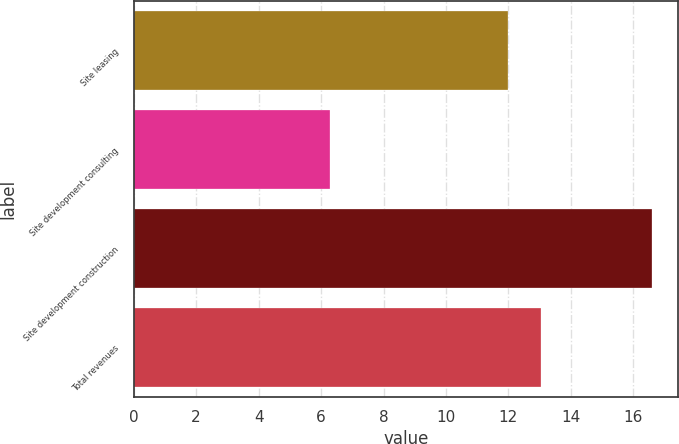Convert chart. <chart><loc_0><loc_0><loc_500><loc_500><bar_chart><fcel>Site leasing<fcel>Site development consulting<fcel>Site development construction<fcel>Total revenues<nl><fcel>12<fcel>6.3<fcel>16.6<fcel>13.03<nl></chart> 